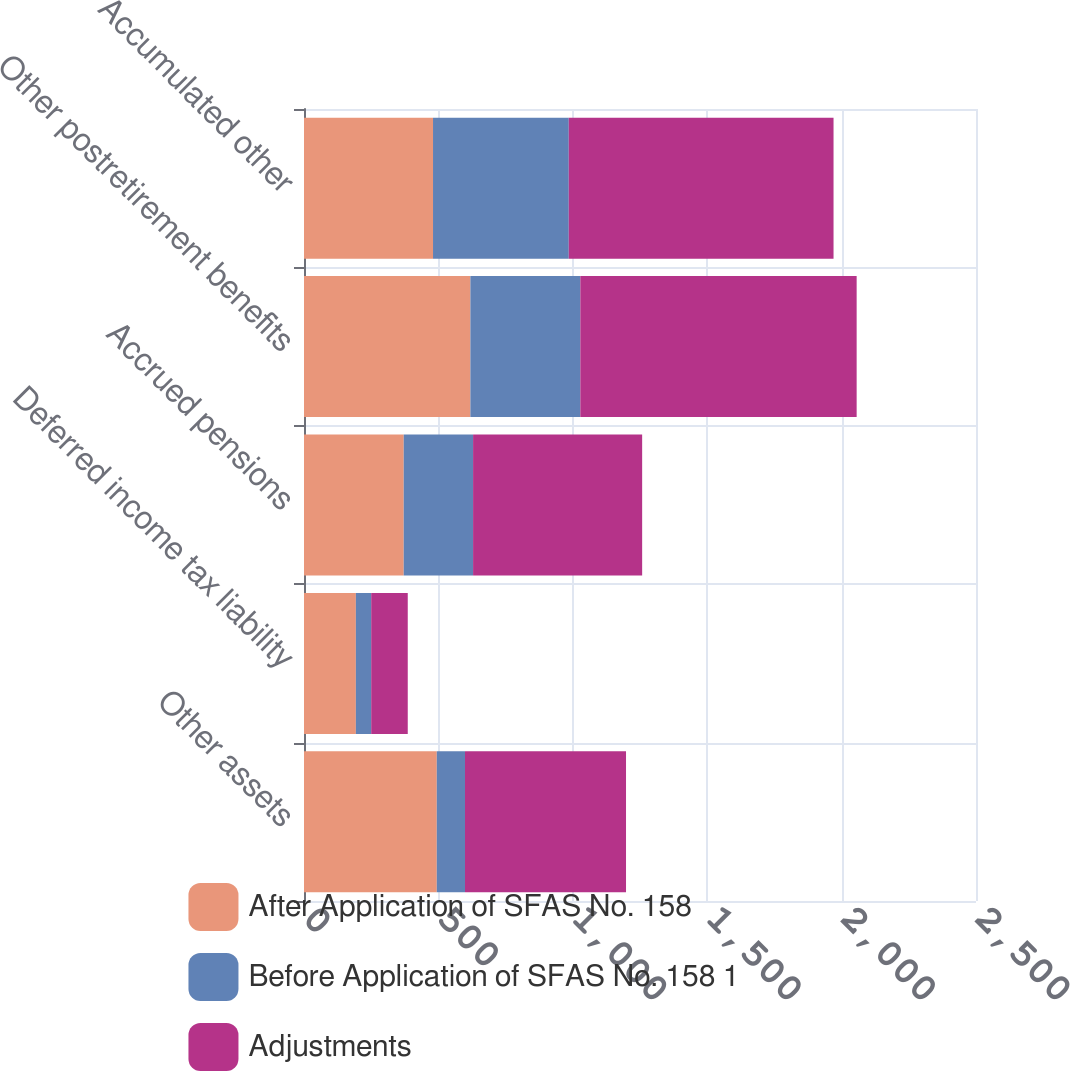Convert chart to OTSL. <chart><loc_0><loc_0><loc_500><loc_500><stacked_bar_chart><ecel><fcel>Other assets<fcel>Deferred income tax liability<fcel>Accrued pensions<fcel>Other postretirement benefits<fcel>Accumulated other<nl><fcel>After Application of SFAS No. 158<fcel>494<fcel>193<fcel>371<fcel>619<fcel>480<nl><fcel>Before Application of SFAS No. 158 1<fcel>105<fcel>57<fcel>258<fcel>409<fcel>505<nl><fcel>Adjustments<fcel>599<fcel>136<fcel>629<fcel>1028<fcel>985<nl></chart> 